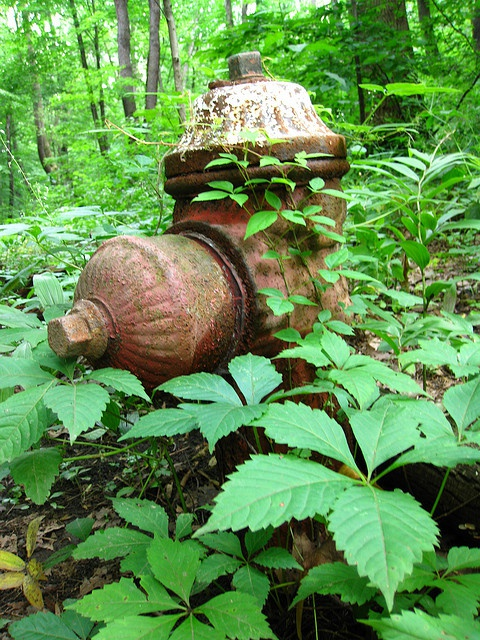Describe the objects in this image and their specific colors. I can see a fire hydrant in lightgreen, black, olive, gray, and tan tones in this image. 